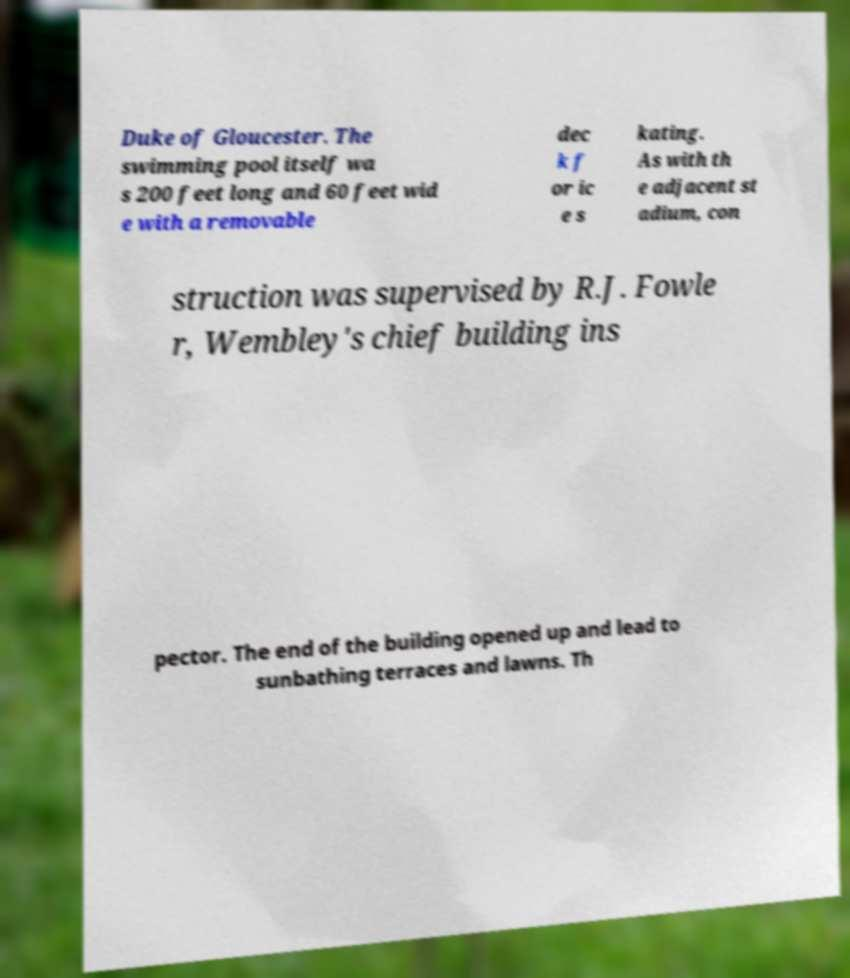I need the written content from this picture converted into text. Can you do that? Duke of Gloucester. The swimming pool itself wa s 200 feet long and 60 feet wid e with a removable dec k f or ic e s kating. As with th e adjacent st adium, con struction was supervised by R.J. Fowle r, Wembley's chief building ins pector. The end of the building opened up and lead to sunbathing terraces and lawns. Th 